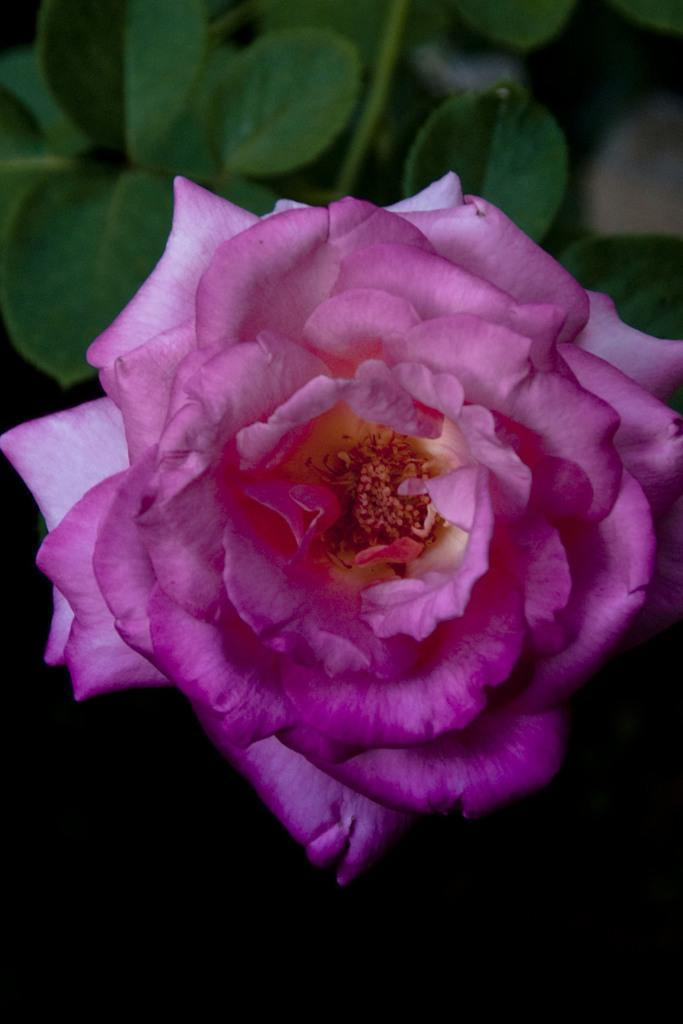What is the main subject in the foreground of the image? There is a pink color flower in the foreground of the image. What can be seen at the top of the image? There are leaves visible at the top of the image. What type of punishment is being administered in the image? There is no indication of punishment in the image; it features a pink flower and leaves. How does the house look in the image? There is no house present in the image; it only contains a pink flower and leaves. 